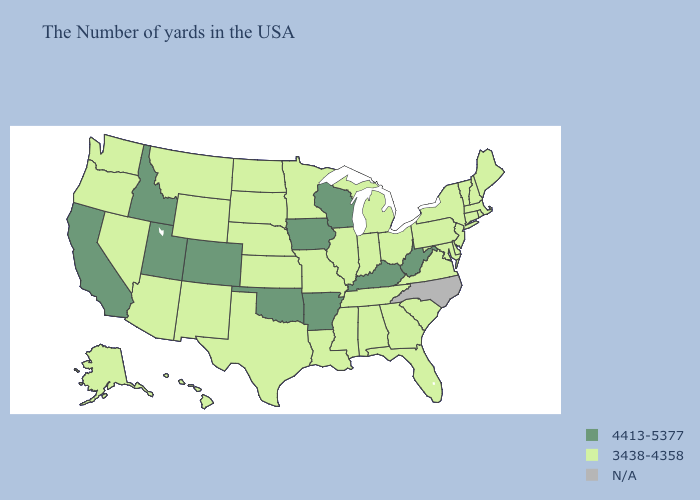Does the map have missing data?
Write a very short answer. Yes. Among the states that border Arizona , which have the highest value?
Answer briefly. Colorado, Utah, California. Does Indiana have the highest value in the USA?
Concise answer only. No. What is the value of New Jersey?
Concise answer only. 3438-4358. What is the value of California?
Be succinct. 4413-5377. What is the value of Washington?
Short answer required. 3438-4358. Which states have the lowest value in the MidWest?
Answer briefly. Ohio, Michigan, Indiana, Illinois, Missouri, Minnesota, Kansas, Nebraska, South Dakota, North Dakota. Among the states that border Tennessee , which have the lowest value?
Short answer required. Virginia, Georgia, Alabama, Mississippi, Missouri. What is the value of Wyoming?
Short answer required. 3438-4358. What is the value of Minnesota?
Write a very short answer. 3438-4358. Name the states that have a value in the range 4413-5377?
Answer briefly. West Virginia, Kentucky, Wisconsin, Arkansas, Iowa, Oklahoma, Colorado, Utah, Idaho, California. Does Utah have the lowest value in the USA?
Quick response, please. No. Name the states that have a value in the range 4413-5377?
Write a very short answer. West Virginia, Kentucky, Wisconsin, Arkansas, Iowa, Oklahoma, Colorado, Utah, Idaho, California. 